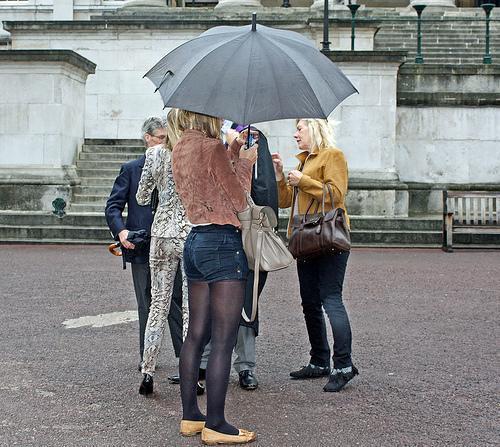How many people are in this photo?
Give a very brief answer. 5. 